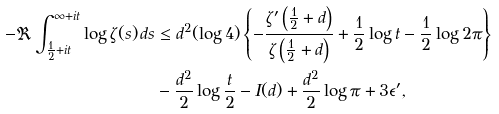<formula> <loc_0><loc_0><loc_500><loc_500>- \Re \int _ { \frac { 1 } { 2 } + i t } ^ { \infty + i t } \log \zeta ( s ) \, d s & \leq d ^ { 2 } ( \log 4 ) \left \{ - \frac { \zeta ^ { \prime } \left ( \frac { 1 } { 2 } + d \right ) } { \zeta \left ( \frac { 1 } { 2 } + d \right ) } + \frac { 1 } { 2 } \log t - \frac { 1 } { 2 } \log 2 \pi \right \} \\ & - \frac { d ^ { 2 } } { 2 } \log \frac { t } { 2 } - I ( d ) + \frac { d ^ { 2 } } { 2 } \log \pi + 3 \epsilon ^ { \prime } ,</formula> 